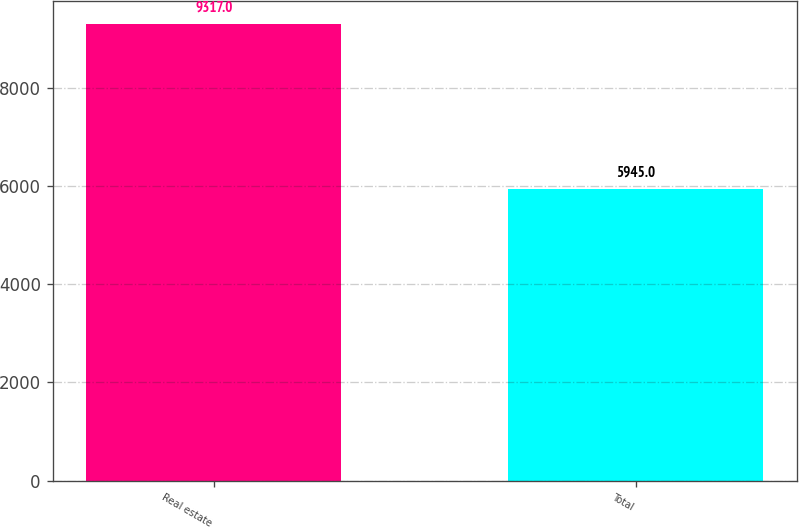Convert chart. <chart><loc_0><loc_0><loc_500><loc_500><bar_chart><fcel>Real estate<fcel>Total<nl><fcel>9317<fcel>5945<nl></chart> 